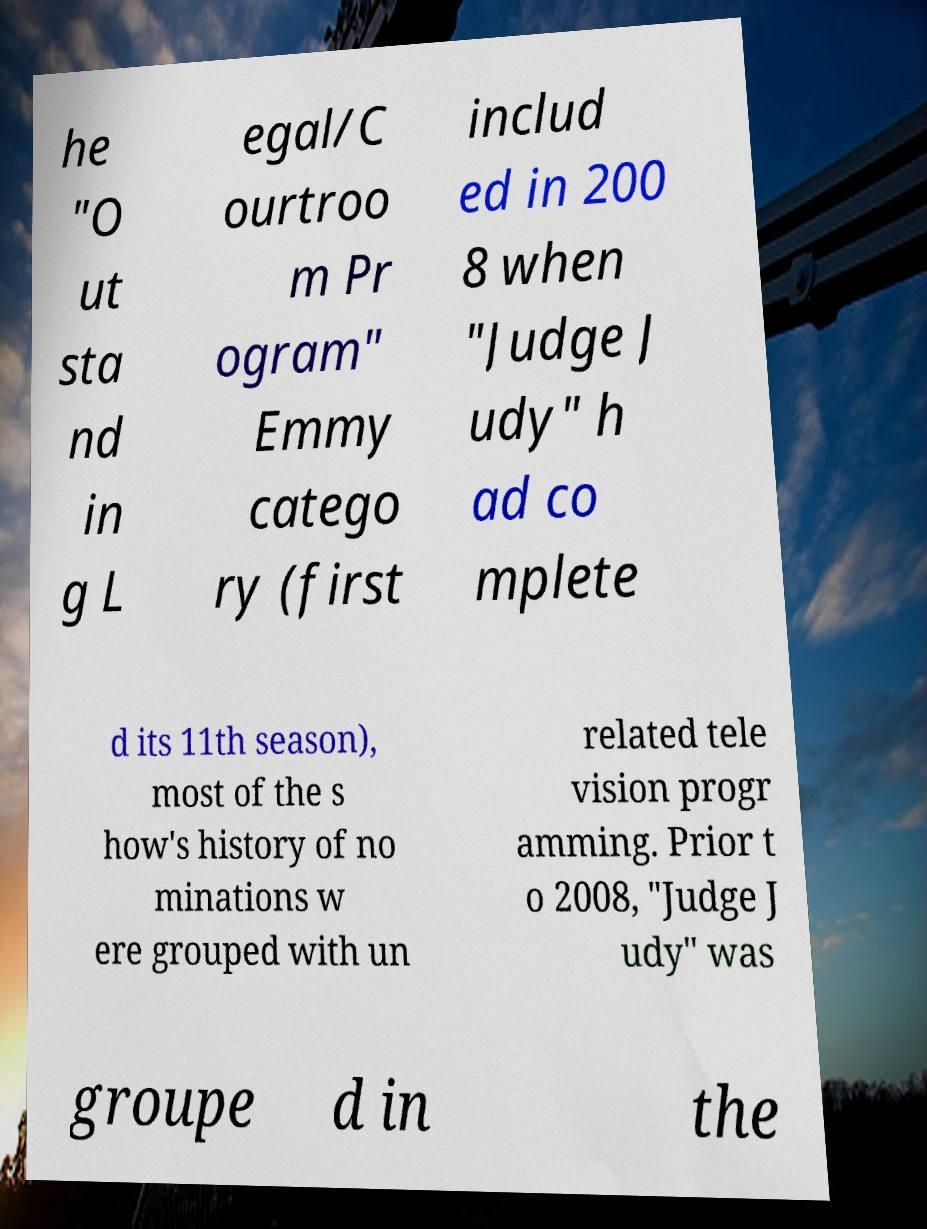Please read and relay the text visible in this image. What does it say? he "O ut sta nd in g L egal/C ourtroo m Pr ogram" Emmy catego ry (first includ ed in 200 8 when "Judge J udy" h ad co mplete d its 11th season), most of the s how's history of no minations w ere grouped with un related tele vision progr amming. Prior t o 2008, "Judge J udy" was groupe d in the 